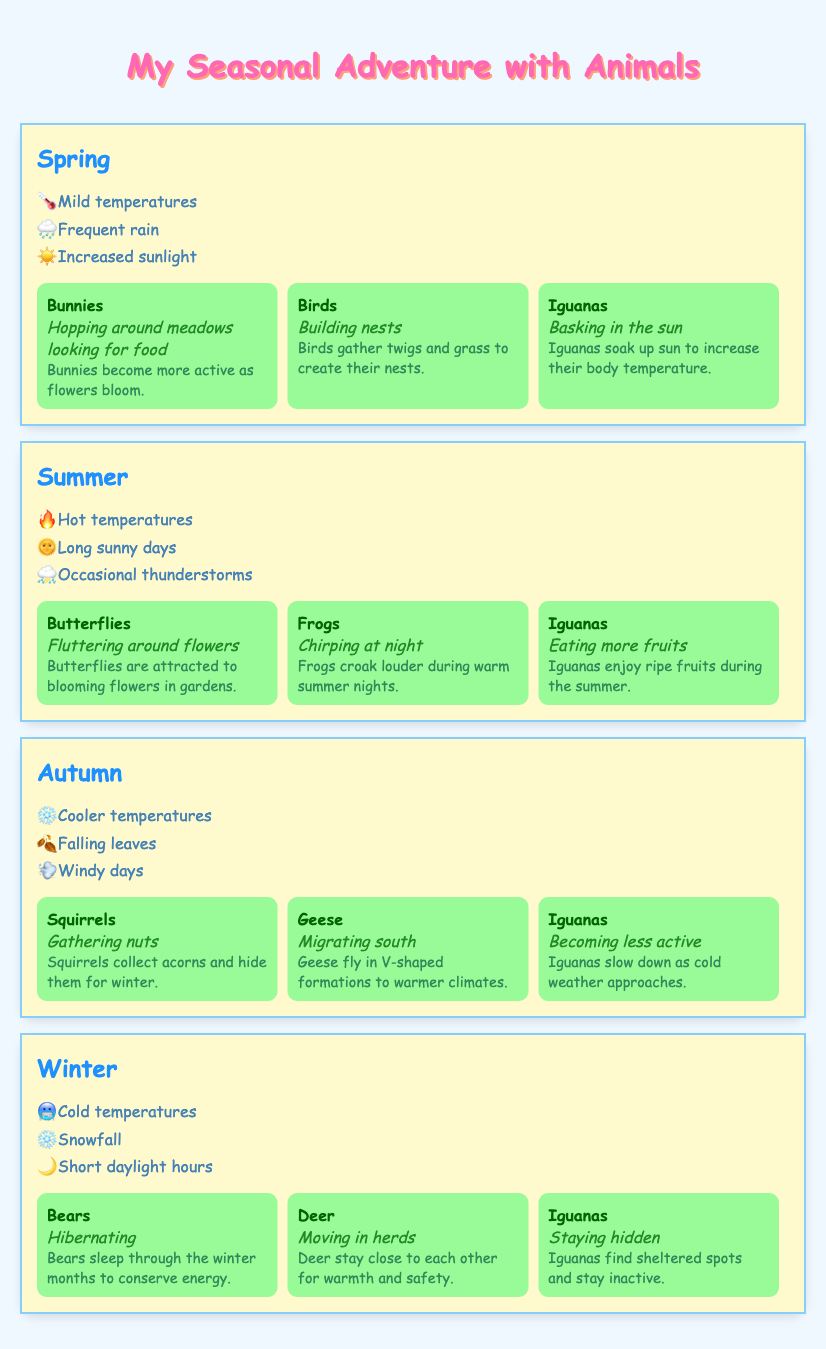What are the weather conditions in Spring? The table lists the weather conditions for Spring as mild temperatures, frequent rain, and increased sunlight. These are clearly stated under the Spring row.
Answer: Mild temperatures, frequent rain, increased sunlight Which animals are most active during Summer? Looking at the Summer section of the table, the animals that are most active during this season are Butterflies, Frogs, and Iguanas.
Answer: Butterflies, Frogs, Iguanas How do Iguanas behave differently in Autumn compared to Summer? In the Summer, Iguanas are eating more fruits, while in Autumn, they are becoming less active due to cooler temperatures. This information is listed under the respective seasons.
Answer: Eating more fruits in Summer; becoming less active in Autumn Is it true that Bears hibernate in Winter? The table indicates that during Winter, Bears are indeed hibernating, as this is mentioned in the Winter section under animal behavior.
Answer: Yes Which season has animals gathering food? In Spring, Bunnies are hopping around meadows looking for food and in Autumn, Squirrels are gathering nuts. To answer the question, both Spring and Autumn include activities related to gathering food.
Answer: Spring and Autumn What is the average number of animals mentioned in each season? Each season lists three animals. Summing up, we have: 3 (Spring) + 3 (Summer) + 3 (Autumn) + 3 (Winter) = 12 animals in total. Since there are 4 seasons, the average is 12/4 = 3.
Answer: 3 What activity do Iguanas engage in during Winter? In the Winter section, it is mentioned that Iguanas are staying hidden. This is specifically listed under animal behavior in the Winter row.
Answer: Staying hidden Do Geese migrate during Winter? The table states that Geese migrate south during Autumn, not Winter. Therefore, the statement is false.
Answer: No 